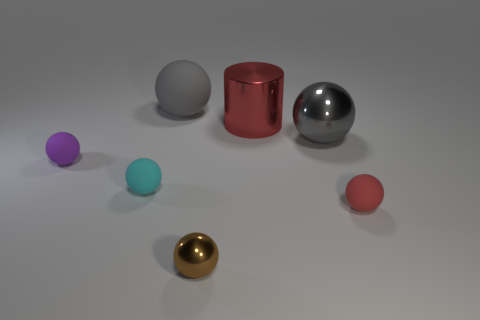Does the big gray matte thing have the same shape as the small brown metal thing?
Keep it short and to the point. Yes. What number of other rubber things have the same size as the purple rubber object?
Ensure brevity in your answer.  2. Is the number of things on the left side of the red metal cylinder less than the number of small metallic things?
Your response must be concise. No. What size is the matte sphere on the right side of the big gray sphere left of the large red shiny thing?
Provide a short and direct response. Small. How many objects are either gray objects or brown shiny balls?
Provide a succinct answer. 3. Is there a shiny object of the same color as the small metallic sphere?
Provide a succinct answer. No. Are there fewer tiny red metallic cubes than small brown metal things?
Ensure brevity in your answer.  Yes. How many things are small cyan rubber cubes or things in front of the large rubber object?
Offer a terse response. 6. Are there any red things that have the same material as the small brown thing?
Give a very brief answer. Yes. There is a red sphere that is the same size as the cyan sphere; what is its material?
Your answer should be very brief. Rubber. 